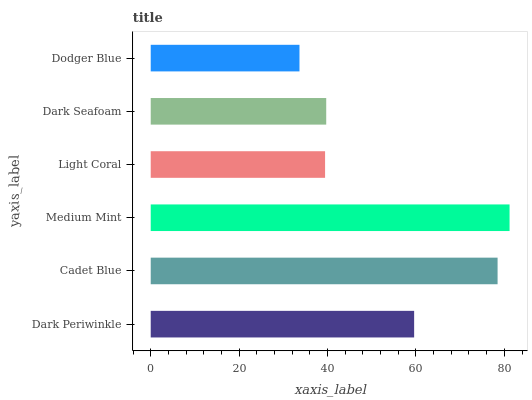Is Dodger Blue the minimum?
Answer yes or no. Yes. Is Medium Mint the maximum?
Answer yes or no. Yes. Is Cadet Blue the minimum?
Answer yes or no. No. Is Cadet Blue the maximum?
Answer yes or no. No. Is Cadet Blue greater than Dark Periwinkle?
Answer yes or no. Yes. Is Dark Periwinkle less than Cadet Blue?
Answer yes or no. Yes. Is Dark Periwinkle greater than Cadet Blue?
Answer yes or no. No. Is Cadet Blue less than Dark Periwinkle?
Answer yes or no. No. Is Dark Periwinkle the high median?
Answer yes or no. Yes. Is Dark Seafoam the low median?
Answer yes or no. Yes. Is Cadet Blue the high median?
Answer yes or no. No. Is Light Coral the low median?
Answer yes or no. No. 